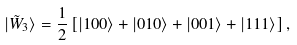<formula> <loc_0><loc_0><loc_500><loc_500>| \tilde { W } _ { 3 } \rangle = \frac { 1 } { 2 } \left [ | 1 0 0 \rangle + | 0 1 0 \rangle + | 0 0 1 \rangle + | 1 1 1 \rangle \right ] ,</formula> 